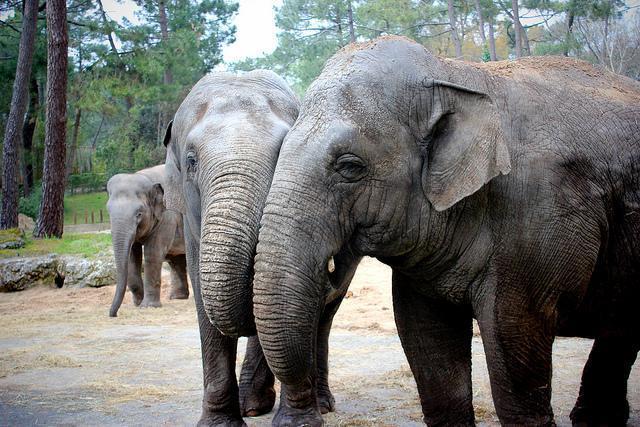How many elephants are there?
Give a very brief answer. 3. How many elephants are in the picture?
Give a very brief answer. 3. 